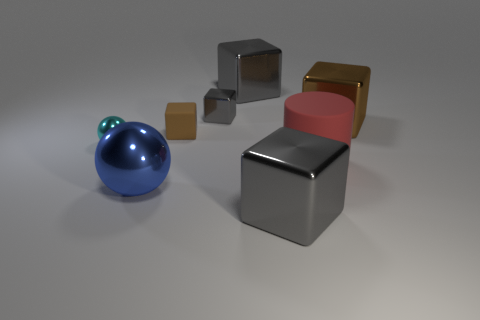Subtract all small cubes. How many cubes are left? 3 Add 1 blue metal spheres. How many objects exist? 9 Subtract all brown cubes. How many cubes are left? 3 Subtract 2 blocks. How many blocks are left? 3 Subtract all blocks. How many objects are left? 3 Subtract all purple blocks. How many cyan balls are left? 1 Subtract all yellow balls. Subtract all green cylinders. How many balls are left? 2 Subtract all cyan objects. Subtract all brown matte cubes. How many objects are left? 6 Add 4 big things. How many big things are left? 9 Add 3 brown matte cubes. How many brown matte cubes exist? 4 